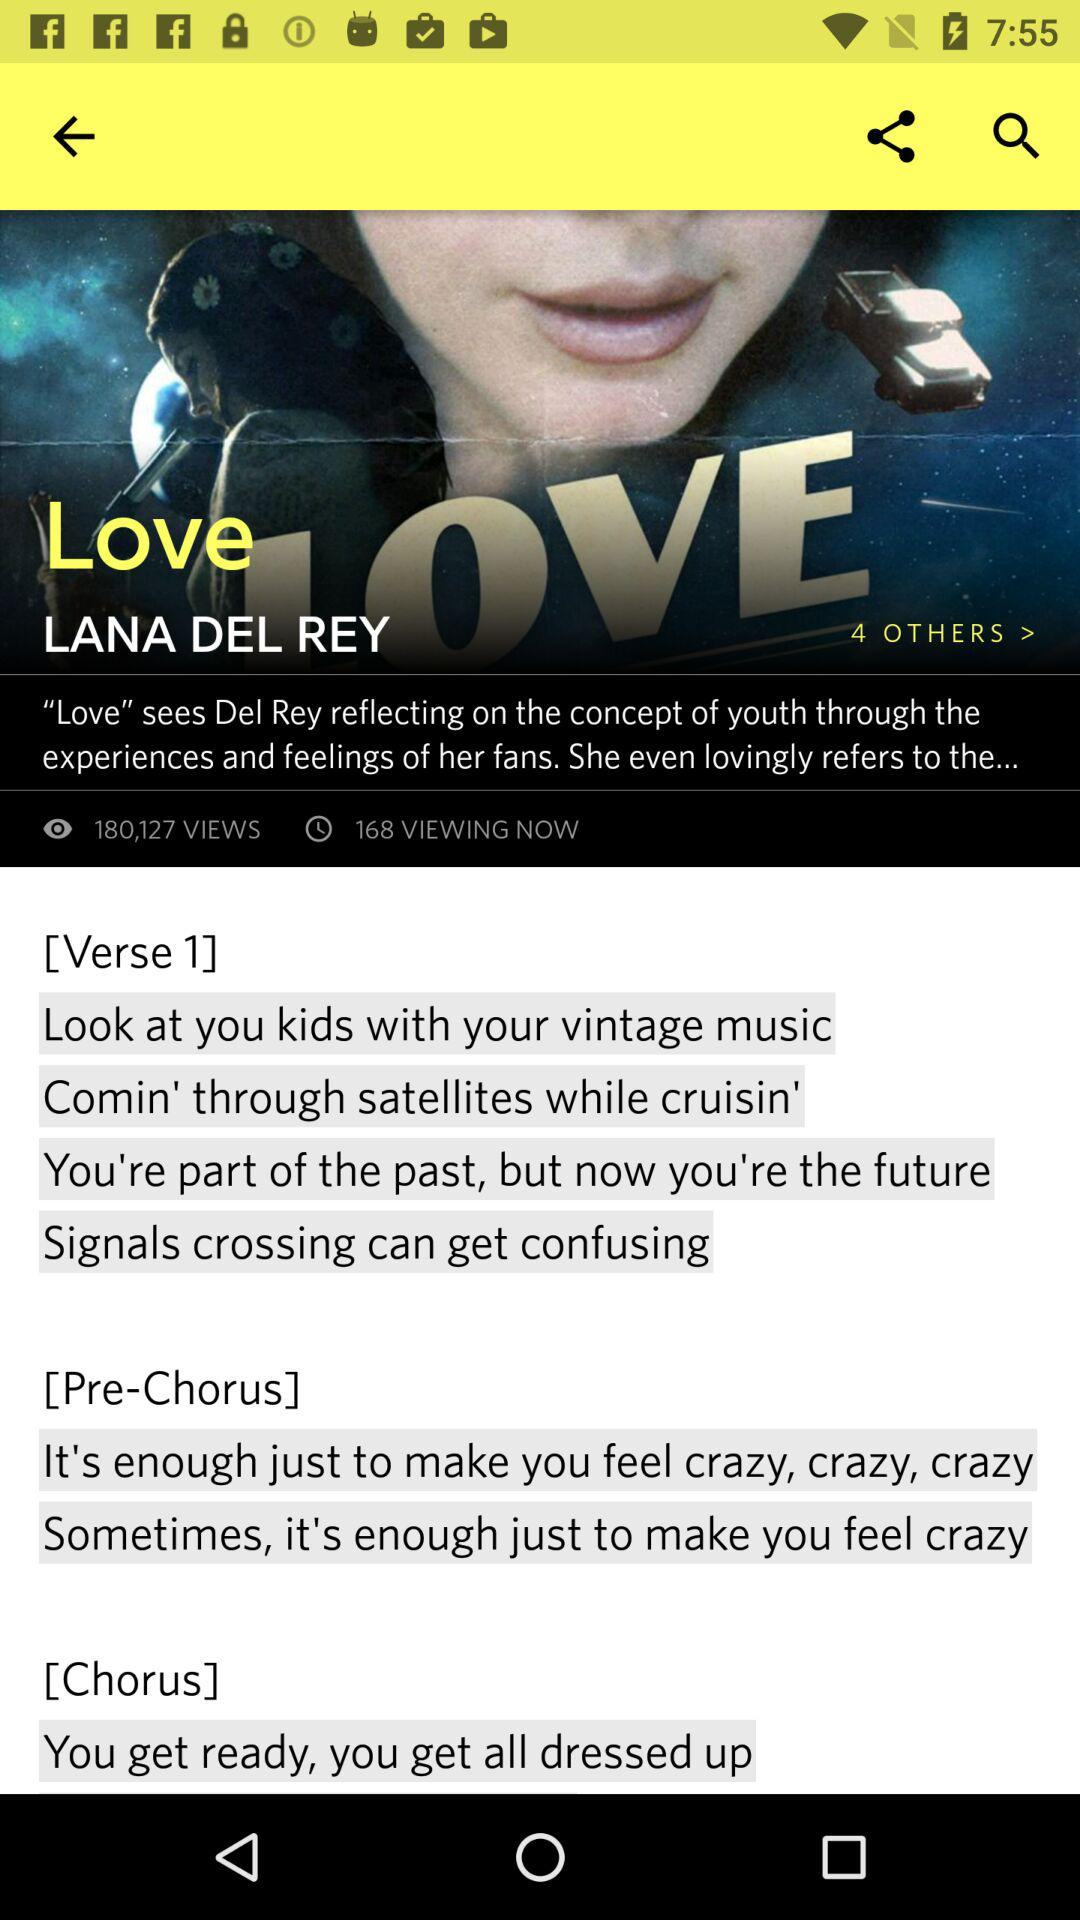How many views are there? There are 180,127 views. 